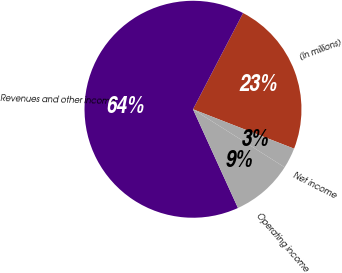<chart> <loc_0><loc_0><loc_500><loc_500><pie_chart><fcel>(In millions)<fcel>Revenues and other income<fcel>Operating income<fcel>Net income<nl><fcel>23.28%<fcel>64.44%<fcel>9.21%<fcel>3.07%<nl></chart> 